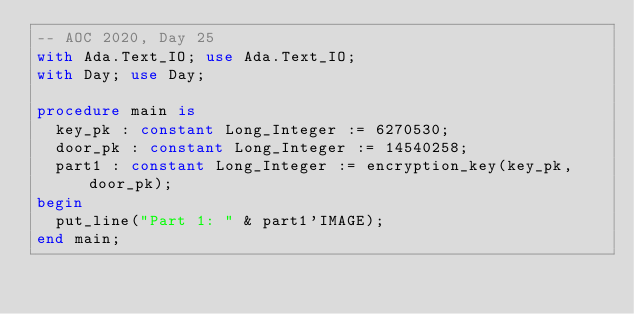<code> <loc_0><loc_0><loc_500><loc_500><_Ada_>-- AOC 2020, Day 25
with Ada.Text_IO; use Ada.Text_IO;
with Day; use Day;

procedure main is
  key_pk : constant Long_Integer := 6270530;
  door_pk : constant Long_Integer := 14540258;
  part1 : constant Long_Integer := encryption_key(key_pk, door_pk);
begin
  put_line("Part 1: " & part1'IMAGE);
end main;
</code> 